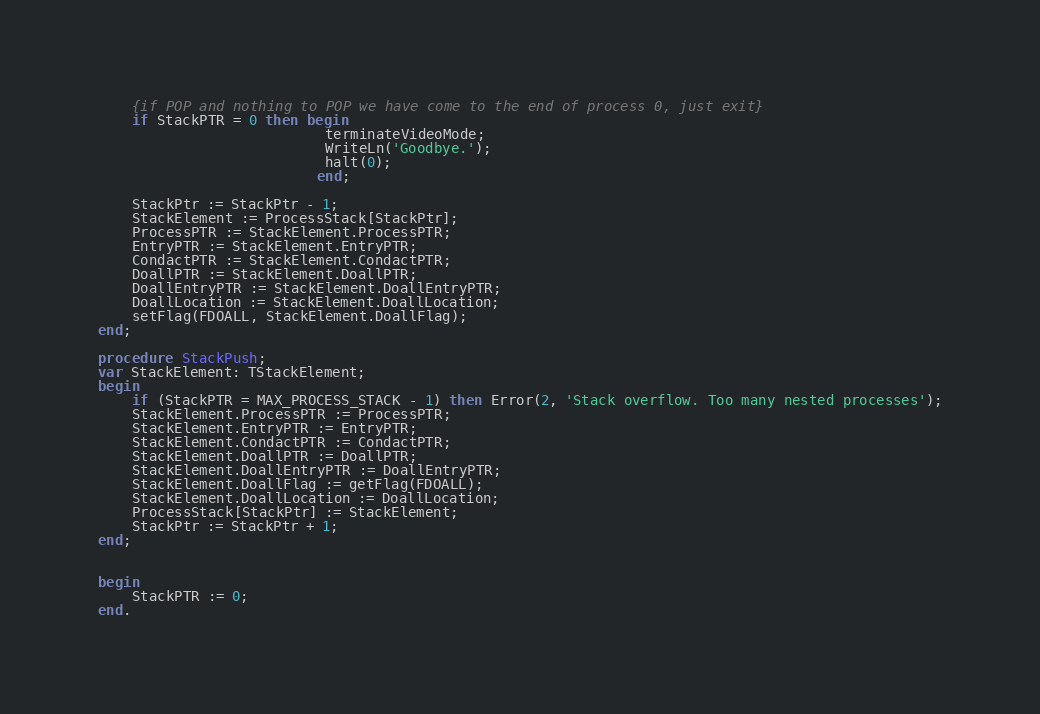<code> <loc_0><loc_0><loc_500><loc_500><_Pascal_>    {if POP and nothing to POP we have come to the end of process 0, just exit}
    if StackPTR = 0 then begin
                           terminateVideoMode; 
                           WriteLn('Goodbye.');
                           halt(0);
                          end;

    StackPtr := StackPtr - 1;
    StackElement := ProcessStack[StackPtr];
    ProcessPTR := StackElement.ProcessPTR;
    EntryPTR := StackElement.EntryPTR;
    CondactPTR := StackElement.CondactPTR;
    DoallPTR := StackElement.DoallPTR;
    DoallEntryPTR := StackElement.DoallEntryPTR;
    DoallLocation := StackElement.DoallLocation;
    setFlag(FDOALL, StackElement.DoallFlag);
end;

procedure StackPush;
var StackElement: TStackElement;    
begin
    if (StackPTR = MAX_PROCESS_STACK - 1) then Error(2, 'Stack overflow. Too many nested processes');
    StackElement.ProcessPTR := ProcessPTR;
    StackElement.EntryPTR := EntryPTR;
    StackElement.CondactPTR := CondactPTR;
    StackElement.DoallPTR := DoallPTR;
    StackElement.DoallEntryPTR := DoallEntryPTR;
    StackElement.DoallFlag := getFlag(FDOALL);
    StackElement.DoallLocation := DoallLocation;
    ProcessStack[StackPtr] := StackElement;
    StackPtr := StackPtr + 1;
end;


begin
    StackPTR := 0;
end.

</code> 